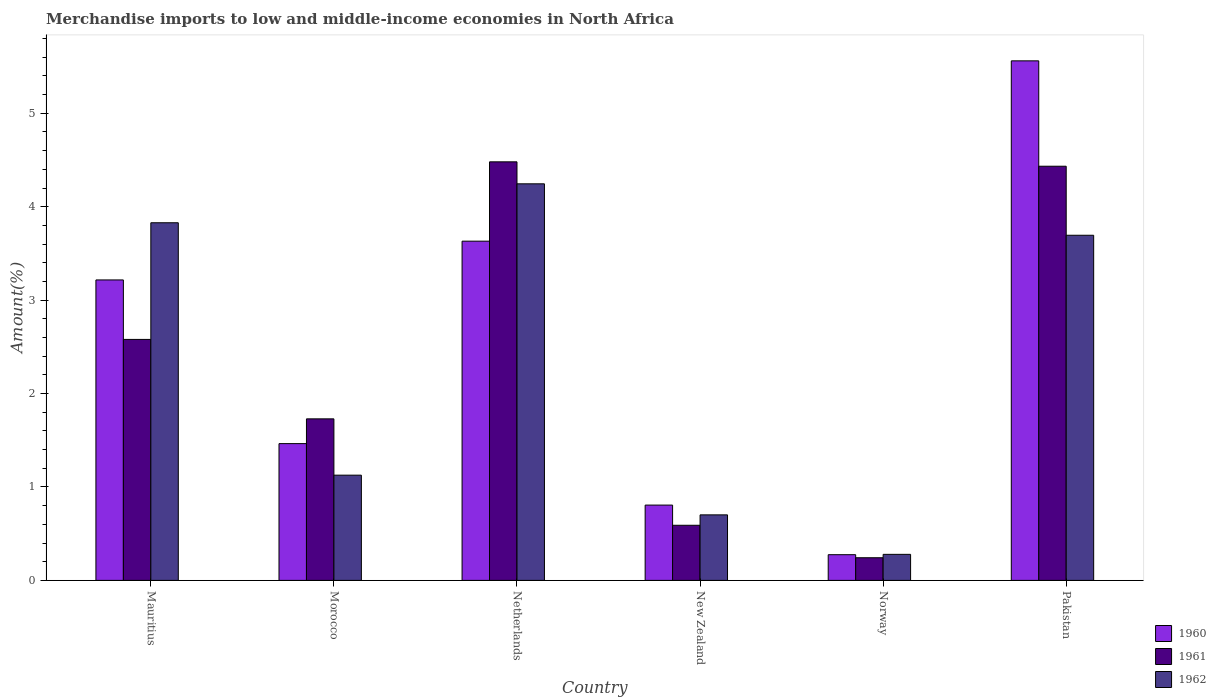How many groups of bars are there?
Keep it short and to the point. 6. How many bars are there on the 1st tick from the left?
Offer a very short reply. 3. What is the label of the 1st group of bars from the left?
Offer a very short reply. Mauritius. What is the percentage of amount earned from merchandise imports in 1962 in Pakistan?
Give a very brief answer. 3.69. Across all countries, what is the maximum percentage of amount earned from merchandise imports in 1960?
Keep it short and to the point. 5.56. Across all countries, what is the minimum percentage of amount earned from merchandise imports in 1962?
Keep it short and to the point. 0.28. In which country was the percentage of amount earned from merchandise imports in 1960 maximum?
Your response must be concise. Pakistan. What is the total percentage of amount earned from merchandise imports in 1962 in the graph?
Your answer should be compact. 13.87. What is the difference between the percentage of amount earned from merchandise imports in 1960 in Mauritius and that in Morocco?
Make the answer very short. 1.75. What is the difference between the percentage of amount earned from merchandise imports in 1960 in Pakistan and the percentage of amount earned from merchandise imports in 1962 in New Zealand?
Your response must be concise. 4.86. What is the average percentage of amount earned from merchandise imports in 1962 per country?
Offer a very short reply. 2.31. What is the difference between the percentage of amount earned from merchandise imports of/in 1962 and percentage of amount earned from merchandise imports of/in 1960 in Netherlands?
Offer a terse response. 0.61. What is the ratio of the percentage of amount earned from merchandise imports in 1962 in New Zealand to that in Pakistan?
Your answer should be compact. 0.19. Is the percentage of amount earned from merchandise imports in 1962 in Mauritius less than that in Morocco?
Keep it short and to the point. No. What is the difference between the highest and the second highest percentage of amount earned from merchandise imports in 1961?
Provide a short and direct response. -1.9. What is the difference between the highest and the lowest percentage of amount earned from merchandise imports in 1960?
Provide a short and direct response. 5.29. Is the sum of the percentage of amount earned from merchandise imports in 1962 in Morocco and Netherlands greater than the maximum percentage of amount earned from merchandise imports in 1960 across all countries?
Make the answer very short. No. What does the 3rd bar from the right in Pakistan represents?
Ensure brevity in your answer.  1960. Are all the bars in the graph horizontal?
Keep it short and to the point. No. How many countries are there in the graph?
Offer a terse response. 6. What is the difference between two consecutive major ticks on the Y-axis?
Your answer should be very brief. 1. Are the values on the major ticks of Y-axis written in scientific E-notation?
Your response must be concise. No. Does the graph contain any zero values?
Your answer should be very brief. No. Where does the legend appear in the graph?
Give a very brief answer. Bottom right. How many legend labels are there?
Make the answer very short. 3. What is the title of the graph?
Keep it short and to the point. Merchandise imports to low and middle-income economies in North Africa. What is the label or title of the Y-axis?
Offer a terse response. Amount(%). What is the Amount(%) of 1960 in Mauritius?
Provide a short and direct response. 3.22. What is the Amount(%) in 1961 in Mauritius?
Give a very brief answer. 2.58. What is the Amount(%) in 1962 in Mauritius?
Ensure brevity in your answer.  3.83. What is the Amount(%) of 1960 in Morocco?
Keep it short and to the point. 1.46. What is the Amount(%) of 1961 in Morocco?
Make the answer very short. 1.73. What is the Amount(%) in 1962 in Morocco?
Give a very brief answer. 1.13. What is the Amount(%) of 1960 in Netherlands?
Provide a succinct answer. 3.63. What is the Amount(%) in 1961 in Netherlands?
Give a very brief answer. 4.48. What is the Amount(%) of 1962 in Netherlands?
Offer a terse response. 4.25. What is the Amount(%) of 1960 in New Zealand?
Make the answer very short. 0.81. What is the Amount(%) of 1961 in New Zealand?
Make the answer very short. 0.59. What is the Amount(%) of 1962 in New Zealand?
Provide a succinct answer. 0.7. What is the Amount(%) of 1960 in Norway?
Offer a very short reply. 0.28. What is the Amount(%) in 1961 in Norway?
Your answer should be very brief. 0.24. What is the Amount(%) of 1962 in Norway?
Keep it short and to the point. 0.28. What is the Amount(%) in 1960 in Pakistan?
Offer a terse response. 5.56. What is the Amount(%) in 1961 in Pakistan?
Your answer should be very brief. 4.43. What is the Amount(%) in 1962 in Pakistan?
Your answer should be compact. 3.69. Across all countries, what is the maximum Amount(%) in 1960?
Offer a very short reply. 5.56. Across all countries, what is the maximum Amount(%) in 1961?
Provide a succinct answer. 4.48. Across all countries, what is the maximum Amount(%) of 1962?
Your response must be concise. 4.25. Across all countries, what is the minimum Amount(%) of 1960?
Offer a very short reply. 0.28. Across all countries, what is the minimum Amount(%) in 1961?
Offer a terse response. 0.24. Across all countries, what is the minimum Amount(%) in 1962?
Provide a short and direct response. 0.28. What is the total Amount(%) of 1960 in the graph?
Your answer should be very brief. 14.95. What is the total Amount(%) of 1961 in the graph?
Your answer should be compact. 14.06. What is the total Amount(%) of 1962 in the graph?
Provide a succinct answer. 13.87. What is the difference between the Amount(%) in 1960 in Mauritius and that in Morocco?
Your answer should be very brief. 1.75. What is the difference between the Amount(%) of 1961 in Mauritius and that in Morocco?
Offer a terse response. 0.85. What is the difference between the Amount(%) of 1962 in Mauritius and that in Morocco?
Ensure brevity in your answer.  2.7. What is the difference between the Amount(%) in 1960 in Mauritius and that in Netherlands?
Keep it short and to the point. -0.41. What is the difference between the Amount(%) in 1961 in Mauritius and that in Netherlands?
Provide a short and direct response. -1.9. What is the difference between the Amount(%) of 1962 in Mauritius and that in Netherlands?
Your answer should be very brief. -0.42. What is the difference between the Amount(%) of 1960 in Mauritius and that in New Zealand?
Give a very brief answer. 2.41. What is the difference between the Amount(%) in 1961 in Mauritius and that in New Zealand?
Offer a very short reply. 1.99. What is the difference between the Amount(%) in 1962 in Mauritius and that in New Zealand?
Provide a short and direct response. 3.13. What is the difference between the Amount(%) in 1960 in Mauritius and that in Norway?
Your answer should be very brief. 2.94. What is the difference between the Amount(%) of 1961 in Mauritius and that in Norway?
Make the answer very short. 2.34. What is the difference between the Amount(%) in 1962 in Mauritius and that in Norway?
Make the answer very short. 3.55. What is the difference between the Amount(%) of 1960 in Mauritius and that in Pakistan?
Your response must be concise. -2.35. What is the difference between the Amount(%) in 1961 in Mauritius and that in Pakistan?
Make the answer very short. -1.85. What is the difference between the Amount(%) of 1962 in Mauritius and that in Pakistan?
Offer a very short reply. 0.13. What is the difference between the Amount(%) of 1960 in Morocco and that in Netherlands?
Offer a very short reply. -2.17. What is the difference between the Amount(%) of 1961 in Morocco and that in Netherlands?
Provide a short and direct response. -2.75. What is the difference between the Amount(%) of 1962 in Morocco and that in Netherlands?
Your answer should be very brief. -3.12. What is the difference between the Amount(%) of 1960 in Morocco and that in New Zealand?
Make the answer very short. 0.66. What is the difference between the Amount(%) in 1961 in Morocco and that in New Zealand?
Ensure brevity in your answer.  1.14. What is the difference between the Amount(%) of 1962 in Morocco and that in New Zealand?
Give a very brief answer. 0.43. What is the difference between the Amount(%) of 1960 in Morocco and that in Norway?
Offer a very short reply. 1.19. What is the difference between the Amount(%) in 1961 in Morocco and that in Norway?
Make the answer very short. 1.49. What is the difference between the Amount(%) of 1962 in Morocco and that in Norway?
Give a very brief answer. 0.85. What is the difference between the Amount(%) in 1960 in Morocco and that in Pakistan?
Offer a terse response. -4.1. What is the difference between the Amount(%) of 1961 in Morocco and that in Pakistan?
Provide a short and direct response. -2.7. What is the difference between the Amount(%) of 1962 in Morocco and that in Pakistan?
Your answer should be very brief. -2.57. What is the difference between the Amount(%) in 1960 in Netherlands and that in New Zealand?
Your answer should be very brief. 2.83. What is the difference between the Amount(%) of 1961 in Netherlands and that in New Zealand?
Make the answer very short. 3.89. What is the difference between the Amount(%) in 1962 in Netherlands and that in New Zealand?
Ensure brevity in your answer.  3.54. What is the difference between the Amount(%) of 1960 in Netherlands and that in Norway?
Offer a terse response. 3.36. What is the difference between the Amount(%) in 1961 in Netherlands and that in Norway?
Keep it short and to the point. 4.24. What is the difference between the Amount(%) in 1962 in Netherlands and that in Norway?
Give a very brief answer. 3.97. What is the difference between the Amount(%) in 1960 in Netherlands and that in Pakistan?
Give a very brief answer. -1.93. What is the difference between the Amount(%) of 1961 in Netherlands and that in Pakistan?
Your answer should be very brief. 0.05. What is the difference between the Amount(%) in 1962 in Netherlands and that in Pakistan?
Ensure brevity in your answer.  0.55. What is the difference between the Amount(%) of 1960 in New Zealand and that in Norway?
Provide a short and direct response. 0.53. What is the difference between the Amount(%) of 1961 in New Zealand and that in Norway?
Your response must be concise. 0.35. What is the difference between the Amount(%) of 1962 in New Zealand and that in Norway?
Make the answer very short. 0.42. What is the difference between the Amount(%) of 1960 in New Zealand and that in Pakistan?
Give a very brief answer. -4.76. What is the difference between the Amount(%) in 1961 in New Zealand and that in Pakistan?
Keep it short and to the point. -3.84. What is the difference between the Amount(%) in 1962 in New Zealand and that in Pakistan?
Keep it short and to the point. -2.99. What is the difference between the Amount(%) of 1960 in Norway and that in Pakistan?
Give a very brief answer. -5.29. What is the difference between the Amount(%) in 1961 in Norway and that in Pakistan?
Offer a very short reply. -4.19. What is the difference between the Amount(%) of 1962 in Norway and that in Pakistan?
Give a very brief answer. -3.42. What is the difference between the Amount(%) in 1960 in Mauritius and the Amount(%) in 1961 in Morocco?
Your answer should be compact. 1.49. What is the difference between the Amount(%) in 1960 in Mauritius and the Amount(%) in 1962 in Morocco?
Your response must be concise. 2.09. What is the difference between the Amount(%) in 1961 in Mauritius and the Amount(%) in 1962 in Morocco?
Keep it short and to the point. 1.45. What is the difference between the Amount(%) in 1960 in Mauritius and the Amount(%) in 1961 in Netherlands?
Your answer should be compact. -1.26. What is the difference between the Amount(%) in 1960 in Mauritius and the Amount(%) in 1962 in Netherlands?
Offer a terse response. -1.03. What is the difference between the Amount(%) of 1961 in Mauritius and the Amount(%) of 1962 in Netherlands?
Provide a short and direct response. -1.67. What is the difference between the Amount(%) in 1960 in Mauritius and the Amount(%) in 1961 in New Zealand?
Provide a short and direct response. 2.63. What is the difference between the Amount(%) in 1960 in Mauritius and the Amount(%) in 1962 in New Zealand?
Make the answer very short. 2.52. What is the difference between the Amount(%) in 1961 in Mauritius and the Amount(%) in 1962 in New Zealand?
Your answer should be compact. 1.88. What is the difference between the Amount(%) in 1960 in Mauritius and the Amount(%) in 1961 in Norway?
Your answer should be very brief. 2.97. What is the difference between the Amount(%) of 1960 in Mauritius and the Amount(%) of 1962 in Norway?
Provide a short and direct response. 2.94. What is the difference between the Amount(%) in 1961 in Mauritius and the Amount(%) in 1962 in Norway?
Your answer should be very brief. 2.3. What is the difference between the Amount(%) of 1960 in Mauritius and the Amount(%) of 1961 in Pakistan?
Make the answer very short. -1.22. What is the difference between the Amount(%) in 1960 in Mauritius and the Amount(%) in 1962 in Pakistan?
Provide a short and direct response. -0.48. What is the difference between the Amount(%) in 1961 in Mauritius and the Amount(%) in 1962 in Pakistan?
Make the answer very short. -1.11. What is the difference between the Amount(%) of 1960 in Morocco and the Amount(%) of 1961 in Netherlands?
Give a very brief answer. -3.02. What is the difference between the Amount(%) of 1960 in Morocco and the Amount(%) of 1962 in Netherlands?
Ensure brevity in your answer.  -2.78. What is the difference between the Amount(%) of 1961 in Morocco and the Amount(%) of 1962 in Netherlands?
Provide a short and direct response. -2.52. What is the difference between the Amount(%) in 1960 in Morocco and the Amount(%) in 1961 in New Zealand?
Offer a terse response. 0.87. What is the difference between the Amount(%) in 1960 in Morocco and the Amount(%) in 1962 in New Zealand?
Your answer should be very brief. 0.76. What is the difference between the Amount(%) of 1961 in Morocco and the Amount(%) of 1962 in New Zealand?
Make the answer very short. 1.03. What is the difference between the Amount(%) of 1960 in Morocco and the Amount(%) of 1961 in Norway?
Your answer should be compact. 1.22. What is the difference between the Amount(%) of 1960 in Morocco and the Amount(%) of 1962 in Norway?
Your response must be concise. 1.19. What is the difference between the Amount(%) of 1961 in Morocco and the Amount(%) of 1962 in Norway?
Provide a succinct answer. 1.45. What is the difference between the Amount(%) in 1960 in Morocco and the Amount(%) in 1961 in Pakistan?
Make the answer very short. -2.97. What is the difference between the Amount(%) of 1960 in Morocco and the Amount(%) of 1962 in Pakistan?
Your response must be concise. -2.23. What is the difference between the Amount(%) of 1961 in Morocco and the Amount(%) of 1962 in Pakistan?
Your answer should be very brief. -1.97. What is the difference between the Amount(%) in 1960 in Netherlands and the Amount(%) in 1961 in New Zealand?
Keep it short and to the point. 3.04. What is the difference between the Amount(%) in 1960 in Netherlands and the Amount(%) in 1962 in New Zealand?
Make the answer very short. 2.93. What is the difference between the Amount(%) of 1961 in Netherlands and the Amount(%) of 1962 in New Zealand?
Give a very brief answer. 3.78. What is the difference between the Amount(%) in 1960 in Netherlands and the Amount(%) in 1961 in Norway?
Provide a succinct answer. 3.39. What is the difference between the Amount(%) of 1960 in Netherlands and the Amount(%) of 1962 in Norway?
Your answer should be very brief. 3.35. What is the difference between the Amount(%) of 1961 in Netherlands and the Amount(%) of 1962 in Norway?
Give a very brief answer. 4.2. What is the difference between the Amount(%) of 1960 in Netherlands and the Amount(%) of 1961 in Pakistan?
Keep it short and to the point. -0.8. What is the difference between the Amount(%) in 1960 in Netherlands and the Amount(%) in 1962 in Pakistan?
Your response must be concise. -0.06. What is the difference between the Amount(%) in 1961 in Netherlands and the Amount(%) in 1962 in Pakistan?
Offer a very short reply. 0.79. What is the difference between the Amount(%) of 1960 in New Zealand and the Amount(%) of 1961 in Norway?
Offer a very short reply. 0.56. What is the difference between the Amount(%) in 1960 in New Zealand and the Amount(%) in 1962 in Norway?
Provide a short and direct response. 0.53. What is the difference between the Amount(%) of 1961 in New Zealand and the Amount(%) of 1962 in Norway?
Ensure brevity in your answer.  0.31. What is the difference between the Amount(%) of 1960 in New Zealand and the Amount(%) of 1961 in Pakistan?
Your response must be concise. -3.63. What is the difference between the Amount(%) in 1960 in New Zealand and the Amount(%) in 1962 in Pakistan?
Your response must be concise. -2.89. What is the difference between the Amount(%) in 1961 in New Zealand and the Amount(%) in 1962 in Pakistan?
Provide a short and direct response. -3.1. What is the difference between the Amount(%) in 1960 in Norway and the Amount(%) in 1961 in Pakistan?
Keep it short and to the point. -4.16. What is the difference between the Amount(%) of 1960 in Norway and the Amount(%) of 1962 in Pakistan?
Your answer should be very brief. -3.42. What is the difference between the Amount(%) of 1961 in Norway and the Amount(%) of 1962 in Pakistan?
Provide a short and direct response. -3.45. What is the average Amount(%) of 1960 per country?
Make the answer very short. 2.49. What is the average Amount(%) of 1961 per country?
Offer a terse response. 2.34. What is the average Amount(%) in 1962 per country?
Give a very brief answer. 2.31. What is the difference between the Amount(%) of 1960 and Amount(%) of 1961 in Mauritius?
Your answer should be very brief. 0.64. What is the difference between the Amount(%) in 1960 and Amount(%) in 1962 in Mauritius?
Keep it short and to the point. -0.61. What is the difference between the Amount(%) in 1961 and Amount(%) in 1962 in Mauritius?
Make the answer very short. -1.25. What is the difference between the Amount(%) of 1960 and Amount(%) of 1961 in Morocco?
Your answer should be very brief. -0.27. What is the difference between the Amount(%) in 1960 and Amount(%) in 1962 in Morocco?
Offer a terse response. 0.34. What is the difference between the Amount(%) of 1961 and Amount(%) of 1962 in Morocco?
Make the answer very short. 0.6. What is the difference between the Amount(%) in 1960 and Amount(%) in 1961 in Netherlands?
Offer a terse response. -0.85. What is the difference between the Amount(%) in 1960 and Amount(%) in 1962 in Netherlands?
Keep it short and to the point. -0.61. What is the difference between the Amount(%) of 1961 and Amount(%) of 1962 in Netherlands?
Your answer should be compact. 0.24. What is the difference between the Amount(%) of 1960 and Amount(%) of 1961 in New Zealand?
Provide a succinct answer. 0.22. What is the difference between the Amount(%) of 1960 and Amount(%) of 1962 in New Zealand?
Ensure brevity in your answer.  0.1. What is the difference between the Amount(%) in 1961 and Amount(%) in 1962 in New Zealand?
Offer a very short reply. -0.11. What is the difference between the Amount(%) of 1960 and Amount(%) of 1961 in Norway?
Your response must be concise. 0.03. What is the difference between the Amount(%) of 1960 and Amount(%) of 1962 in Norway?
Make the answer very short. -0. What is the difference between the Amount(%) of 1961 and Amount(%) of 1962 in Norway?
Keep it short and to the point. -0.04. What is the difference between the Amount(%) of 1960 and Amount(%) of 1961 in Pakistan?
Your answer should be compact. 1.13. What is the difference between the Amount(%) in 1960 and Amount(%) in 1962 in Pakistan?
Offer a terse response. 1.87. What is the difference between the Amount(%) of 1961 and Amount(%) of 1962 in Pakistan?
Offer a terse response. 0.74. What is the ratio of the Amount(%) in 1960 in Mauritius to that in Morocco?
Make the answer very short. 2.2. What is the ratio of the Amount(%) in 1961 in Mauritius to that in Morocco?
Ensure brevity in your answer.  1.49. What is the ratio of the Amount(%) of 1962 in Mauritius to that in Morocco?
Provide a short and direct response. 3.4. What is the ratio of the Amount(%) of 1960 in Mauritius to that in Netherlands?
Your answer should be compact. 0.89. What is the ratio of the Amount(%) of 1961 in Mauritius to that in Netherlands?
Keep it short and to the point. 0.58. What is the ratio of the Amount(%) of 1962 in Mauritius to that in Netherlands?
Offer a very short reply. 0.9. What is the ratio of the Amount(%) of 1960 in Mauritius to that in New Zealand?
Provide a succinct answer. 3.99. What is the ratio of the Amount(%) in 1961 in Mauritius to that in New Zealand?
Your answer should be compact. 4.37. What is the ratio of the Amount(%) in 1962 in Mauritius to that in New Zealand?
Make the answer very short. 5.46. What is the ratio of the Amount(%) in 1960 in Mauritius to that in Norway?
Offer a very short reply. 11.69. What is the ratio of the Amount(%) in 1961 in Mauritius to that in Norway?
Offer a terse response. 10.64. What is the ratio of the Amount(%) of 1962 in Mauritius to that in Norway?
Provide a short and direct response. 13.73. What is the ratio of the Amount(%) in 1960 in Mauritius to that in Pakistan?
Your answer should be compact. 0.58. What is the ratio of the Amount(%) of 1961 in Mauritius to that in Pakistan?
Provide a short and direct response. 0.58. What is the ratio of the Amount(%) in 1962 in Mauritius to that in Pakistan?
Your answer should be compact. 1.04. What is the ratio of the Amount(%) in 1960 in Morocco to that in Netherlands?
Offer a very short reply. 0.4. What is the ratio of the Amount(%) in 1961 in Morocco to that in Netherlands?
Provide a short and direct response. 0.39. What is the ratio of the Amount(%) of 1962 in Morocco to that in Netherlands?
Your answer should be compact. 0.27. What is the ratio of the Amount(%) in 1960 in Morocco to that in New Zealand?
Give a very brief answer. 1.82. What is the ratio of the Amount(%) of 1961 in Morocco to that in New Zealand?
Make the answer very short. 2.93. What is the ratio of the Amount(%) in 1962 in Morocco to that in New Zealand?
Offer a very short reply. 1.61. What is the ratio of the Amount(%) in 1960 in Morocco to that in Norway?
Your response must be concise. 5.32. What is the ratio of the Amount(%) of 1961 in Morocco to that in Norway?
Offer a very short reply. 7.13. What is the ratio of the Amount(%) of 1962 in Morocco to that in Norway?
Your answer should be compact. 4.04. What is the ratio of the Amount(%) of 1960 in Morocco to that in Pakistan?
Keep it short and to the point. 0.26. What is the ratio of the Amount(%) in 1961 in Morocco to that in Pakistan?
Ensure brevity in your answer.  0.39. What is the ratio of the Amount(%) of 1962 in Morocco to that in Pakistan?
Give a very brief answer. 0.3. What is the ratio of the Amount(%) of 1960 in Netherlands to that in New Zealand?
Keep it short and to the point. 4.5. What is the ratio of the Amount(%) of 1961 in Netherlands to that in New Zealand?
Ensure brevity in your answer.  7.6. What is the ratio of the Amount(%) of 1962 in Netherlands to that in New Zealand?
Your answer should be very brief. 6.05. What is the ratio of the Amount(%) of 1960 in Netherlands to that in Norway?
Ensure brevity in your answer.  13.2. What is the ratio of the Amount(%) of 1961 in Netherlands to that in Norway?
Offer a terse response. 18.48. What is the ratio of the Amount(%) in 1962 in Netherlands to that in Norway?
Your response must be concise. 15.23. What is the ratio of the Amount(%) of 1960 in Netherlands to that in Pakistan?
Make the answer very short. 0.65. What is the ratio of the Amount(%) of 1961 in Netherlands to that in Pakistan?
Keep it short and to the point. 1.01. What is the ratio of the Amount(%) in 1962 in Netherlands to that in Pakistan?
Offer a very short reply. 1.15. What is the ratio of the Amount(%) in 1960 in New Zealand to that in Norway?
Offer a very short reply. 2.93. What is the ratio of the Amount(%) of 1961 in New Zealand to that in Norway?
Offer a very short reply. 2.43. What is the ratio of the Amount(%) of 1962 in New Zealand to that in Norway?
Keep it short and to the point. 2.52. What is the ratio of the Amount(%) in 1960 in New Zealand to that in Pakistan?
Keep it short and to the point. 0.14. What is the ratio of the Amount(%) of 1961 in New Zealand to that in Pakistan?
Keep it short and to the point. 0.13. What is the ratio of the Amount(%) of 1962 in New Zealand to that in Pakistan?
Ensure brevity in your answer.  0.19. What is the ratio of the Amount(%) in 1960 in Norway to that in Pakistan?
Your answer should be compact. 0.05. What is the ratio of the Amount(%) in 1961 in Norway to that in Pakistan?
Keep it short and to the point. 0.05. What is the ratio of the Amount(%) in 1962 in Norway to that in Pakistan?
Offer a very short reply. 0.08. What is the difference between the highest and the second highest Amount(%) in 1960?
Your response must be concise. 1.93. What is the difference between the highest and the second highest Amount(%) of 1961?
Your answer should be very brief. 0.05. What is the difference between the highest and the second highest Amount(%) of 1962?
Your answer should be very brief. 0.42. What is the difference between the highest and the lowest Amount(%) of 1960?
Your answer should be compact. 5.29. What is the difference between the highest and the lowest Amount(%) in 1961?
Offer a terse response. 4.24. What is the difference between the highest and the lowest Amount(%) in 1962?
Your answer should be very brief. 3.97. 